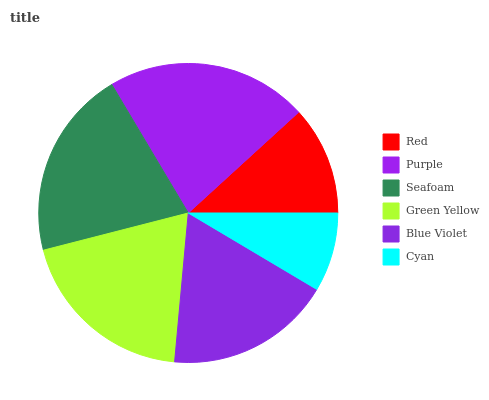Is Cyan the minimum?
Answer yes or no. Yes. Is Purple the maximum?
Answer yes or no. Yes. Is Seafoam the minimum?
Answer yes or no. No. Is Seafoam the maximum?
Answer yes or no. No. Is Purple greater than Seafoam?
Answer yes or no. Yes. Is Seafoam less than Purple?
Answer yes or no. Yes. Is Seafoam greater than Purple?
Answer yes or no. No. Is Purple less than Seafoam?
Answer yes or no. No. Is Green Yellow the high median?
Answer yes or no. Yes. Is Blue Violet the low median?
Answer yes or no. Yes. Is Purple the high median?
Answer yes or no. No. Is Green Yellow the low median?
Answer yes or no. No. 